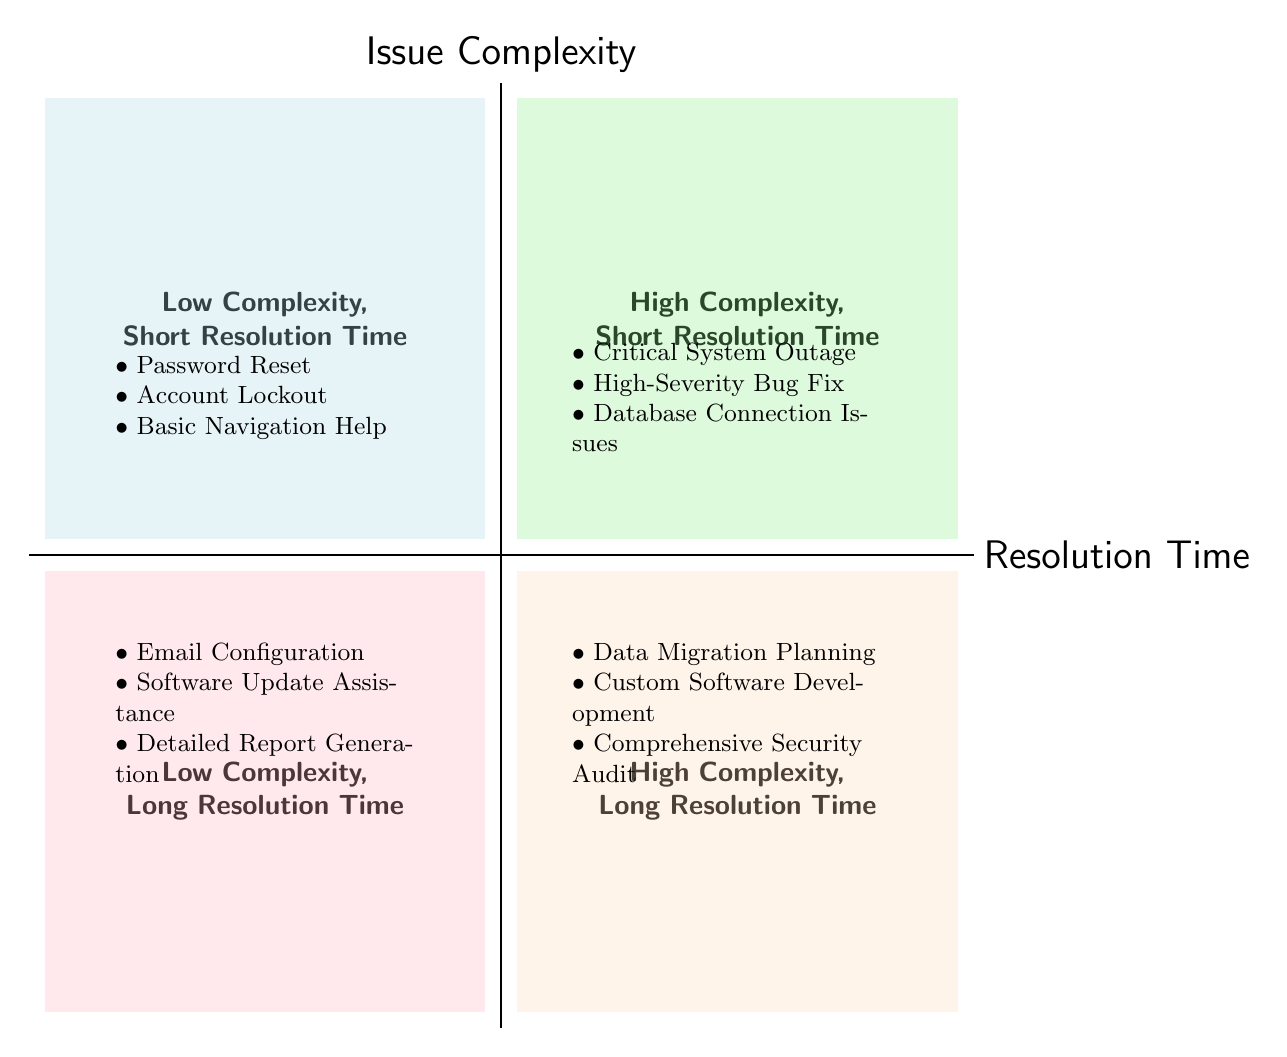What are the issues listed in the Low Complexity, Short Resolution Time quadrant? The Low Complexity, Short Resolution Time quadrant contains three issues: Password Reset, Account Lockout, and Basic Navigation Help. These issues are located in the upper left section of the chart, which indicates a combination of low complexity and short resolution time.
Answer: Password Reset, Account Lockout, Basic Navigation Help How many issues are in the High Complexity, Long Resolution Time quadrant? The High Complexity, Long Resolution Time quadrant has three issues listed: Data Migration Planning, Custom Software Development, and Comprehensive Security Audit. Counting these gives a total of three issues in this quadrant, located in the lower right section of the chart.
Answer: 3 Which issues have a High Complexity but a Short Resolution Time? The issues that fall under High Complexity with Short Resolution Time are Critical System Outage, High-Severity Bug Fix, and Database Connection Issues. These are visible in the upper right section of the chart.
Answer: Critical System Outage, High-Severity Bug Fix, Database Connection Issues What is the relationship between complexity and resolution time for Email Configuration? Email Configuration is categorized under Low Complexity and Long Resolution Time, indicating that while the issue itself is not difficult to handle, it may take longer than simpler issues to reach a resolution. This categorization is found in the lower left section of the chart.
Answer: Low Complexity, Long Resolution Time Which quadrant contains Basic Navigation Help, and what does that indicate? Basic Navigation Help is located in the Low Complexity, Short Resolution Time quadrant, indicating that it is relatively easy to resolve and typically has a quick turnaround time. This is in the upper left section of the chart.
Answer: Low Complexity, Short Resolution Time What type of issues fall under High Complexity? The issues that fall under High Complexity are Critical System Outage, High-Severity Bug Fix, Database Connection Issues, Data Migration Planning, Custom Software Development, and Comprehensive Security Audit. These issues vary in their resolution times, showing that high complexity can exist with both short and long resolution durations.
Answer: Critical System Outage, High-Severity Bug Fix, Database Connection Issues, Data Migration Planning, Custom Software Development, Comprehensive Security Audit In which quadrant are the issues that require the longest resolution time? The issues requiring the longest resolution time are found in the Low Complexity, Long Resolution Time and High Complexity, Long Resolution Time quadrants. Both quadrants indicate that these issues, despite their varying complexities, take longer to resolve than issues in the other quadrants.
Answer: Low Complexity, Long Resolution Time; High Complexity, Long Resolution Time How many quadrants are there in the diagram, and what do they represent? There are four quadrants in the diagram: Low Complexity, Short Resolution Time; High Complexity, Short Resolution Time; Low Complexity, Long Resolution Time; and High Complexity, Long Resolution Time. Each quadrant represents different combinations of issue complexity and resolution time.
Answer: 4 quadrants 